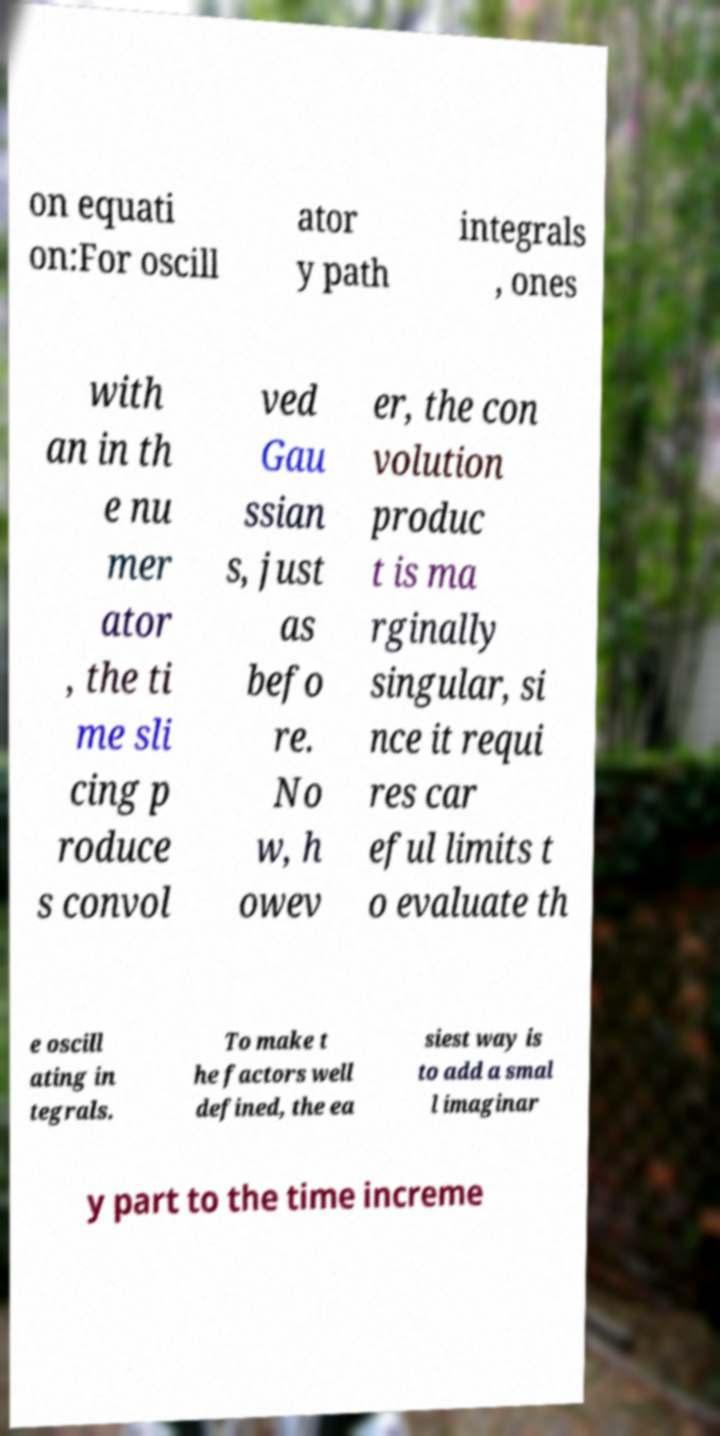I need the written content from this picture converted into text. Can you do that? on equati on:For oscill ator y path integrals , ones with an in th e nu mer ator , the ti me sli cing p roduce s convol ved Gau ssian s, just as befo re. No w, h owev er, the con volution produc t is ma rginally singular, si nce it requi res car eful limits t o evaluate th e oscill ating in tegrals. To make t he factors well defined, the ea siest way is to add a smal l imaginar y part to the time increme 